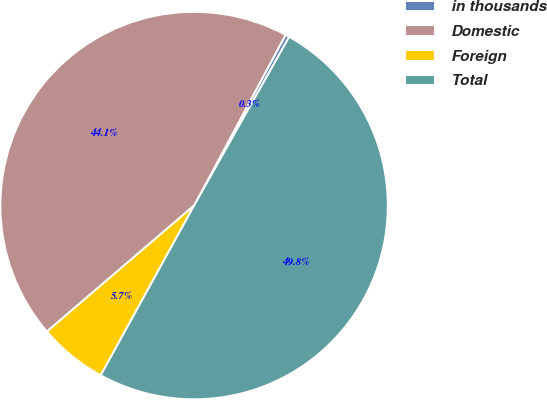Convert chart to OTSL. <chart><loc_0><loc_0><loc_500><loc_500><pie_chart><fcel>in thousands<fcel>Domestic<fcel>Foreign<fcel>Total<nl><fcel>0.34%<fcel>44.1%<fcel>5.73%<fcel>49.83%<nl></chart> 